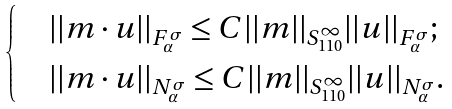Convert formula to latex. <formula><loc_0><loc_0><loc_500><loc_500>\begin{cases} & | | m \cdot u | | _ { F ^ { \sigma } _ { \alpha } } \leq C | | m | | _ { S ^ { \infty } _ { 1 1 0 } } | | u | | _ { F ^ { \sigma } _ { \alpha } } ; \\ & | | m \cdot u | | _ { N ^ { \sigma } _ { \alpha } } \leq C | | m | | _ { S ^ { \infty } _ { 1 1 0 } } | | u | | _ { N ^ { \sigma } _ { \alpha } } . \end{cases}</formula> 